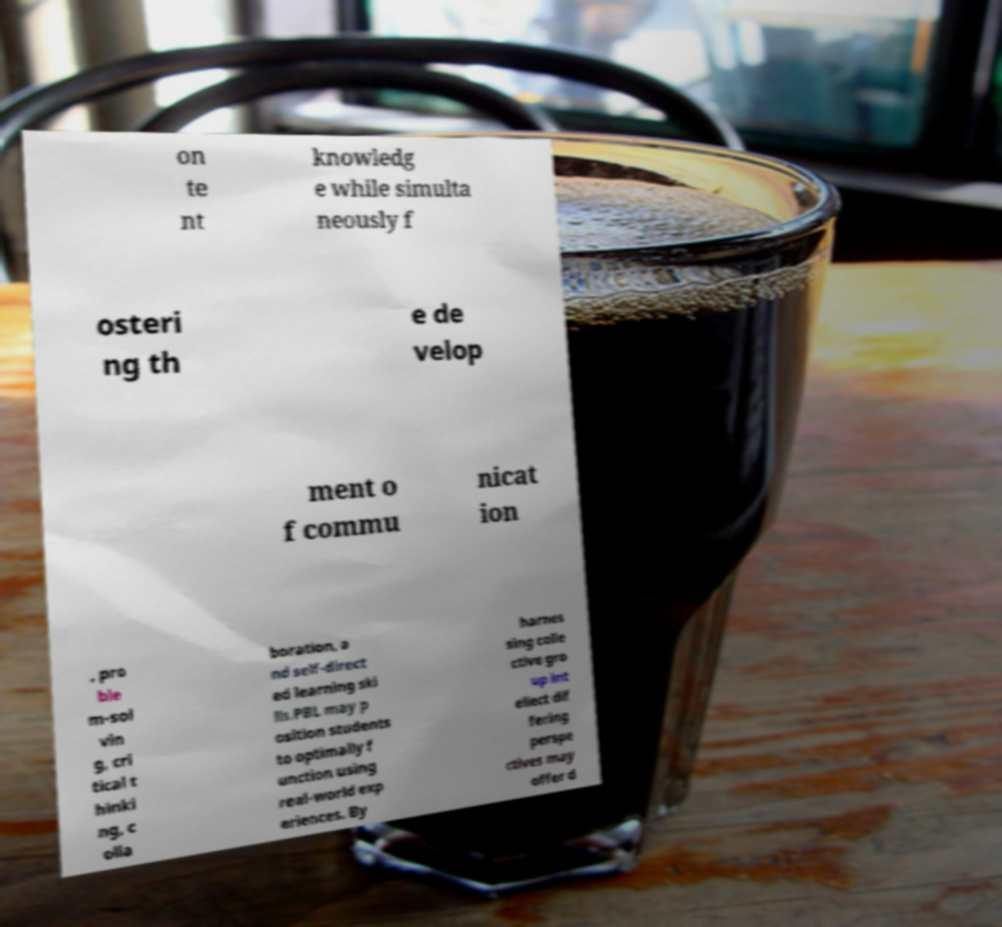There's text embedded in this image that I need extracted. Can you transcribe it verbatim? on te nt knowledg e while simulta neously f osteri ng th e de velop ment o f commu nicat ion , pro ble m-sol vin g, cri tical t hinki ng, c olla boration, a nd self-direct ed learning ski lls.PBL may p osition students to optimally f unction using real-world exp eriences. By harnes sing colle ctive gro up int ellect dif fering perspe ctives may offer d 